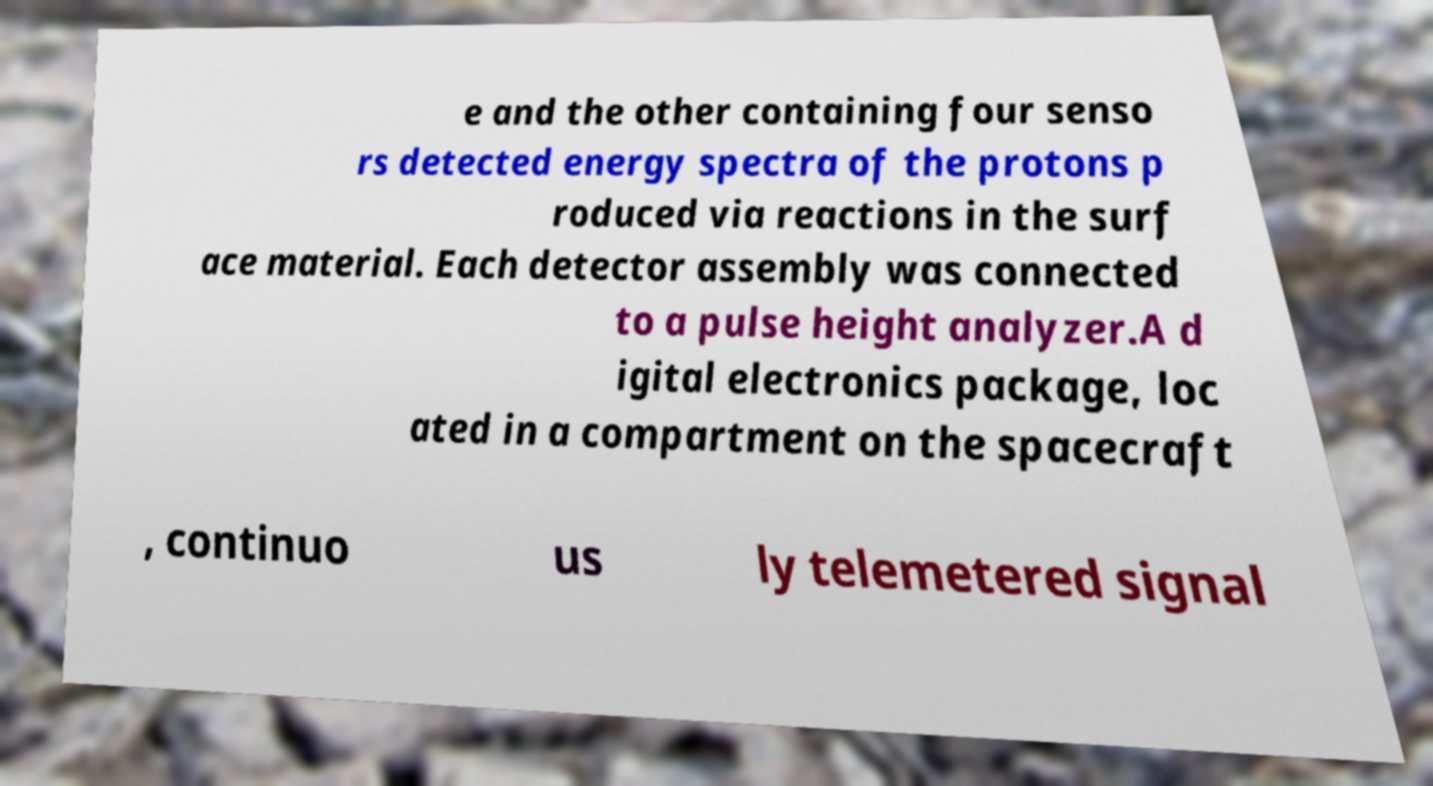I need the written content from this picture converted into text. Can you do that? e and the other containing four senso rs detected energy spectra of the protons p roduced via reactions in the surf ace material. Each detector assembly was connected to a pulse height analyzer.A d igital electronics package, loc ated in a compartment on the spacecraft , continuo us ly telemetered signal 